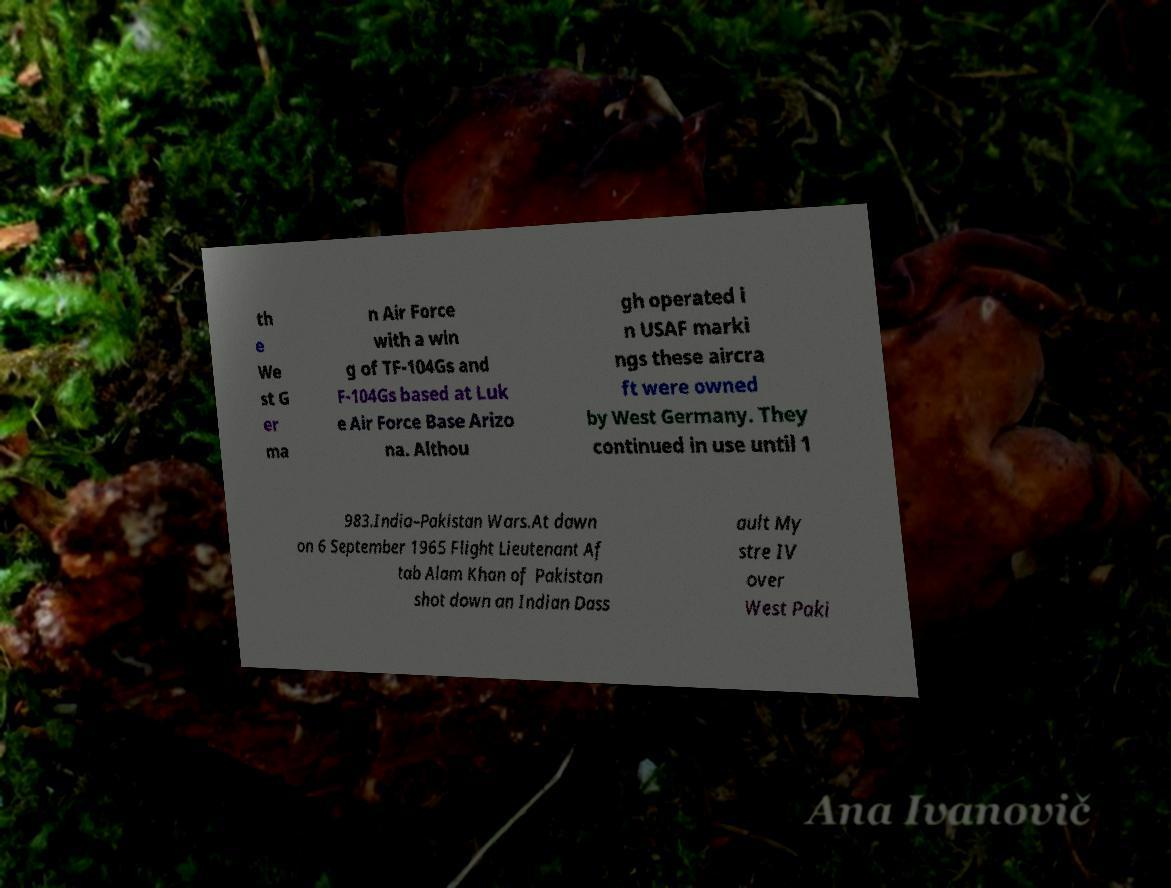Please identify and transcribe the text found in this image. th e We st G er ma n Air Force with a win g of TF-104Gs and F-104Gs based at Luk e Air Force Base Arizo na. Althou gh operated i n USAF marki ngs these aircra ft were owned by West Germany. They continued in use until 1 983.India–Pakistan Wars.At dawn on 6 September 1965 Flight Lieutenant Af tab Alam Khan of Pakistan shot down an Indian Dass ault My stre IV over West Paki 